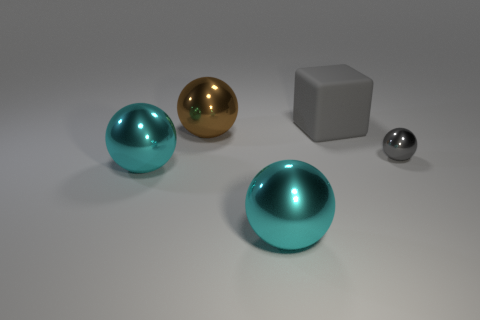Add 4 big gray metal objects. How many objects exist? 9 Subtract all cubes. How many objects are left? 4 Add 3 brown shiny things. How many brown shiny things are left? 4 Add 4 small gray matte balls. How many small gray matte balls exist? 4 Subtract 0 red cylinders. How many objects are left? 5 Subtract all yellow metal blocks. Subtract all brown shiny objects. How many objects are left? 4 